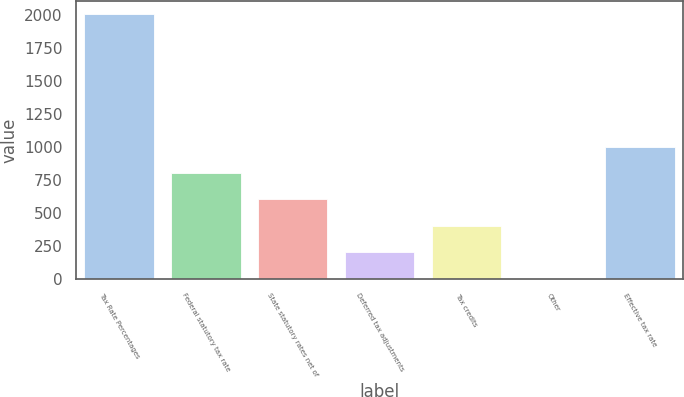Convert chart. <chart><loc_0><loc_0><loc_500><loc_500><bar_chart><fcel>Tax Rate Percentages<fcel>Federal statutory tax rate<fcel>State statutory rates net of<fcel>Deferred tax adjustments<fcel>Tax credits<fcel>Other<fcel>Effective tax rate<nl><fcel>2009<fcel>803.72<fcel>602.84<fcel>201.08<fcel>401.96<fcel>0.2<fcel>1004.6<nl></chart> 